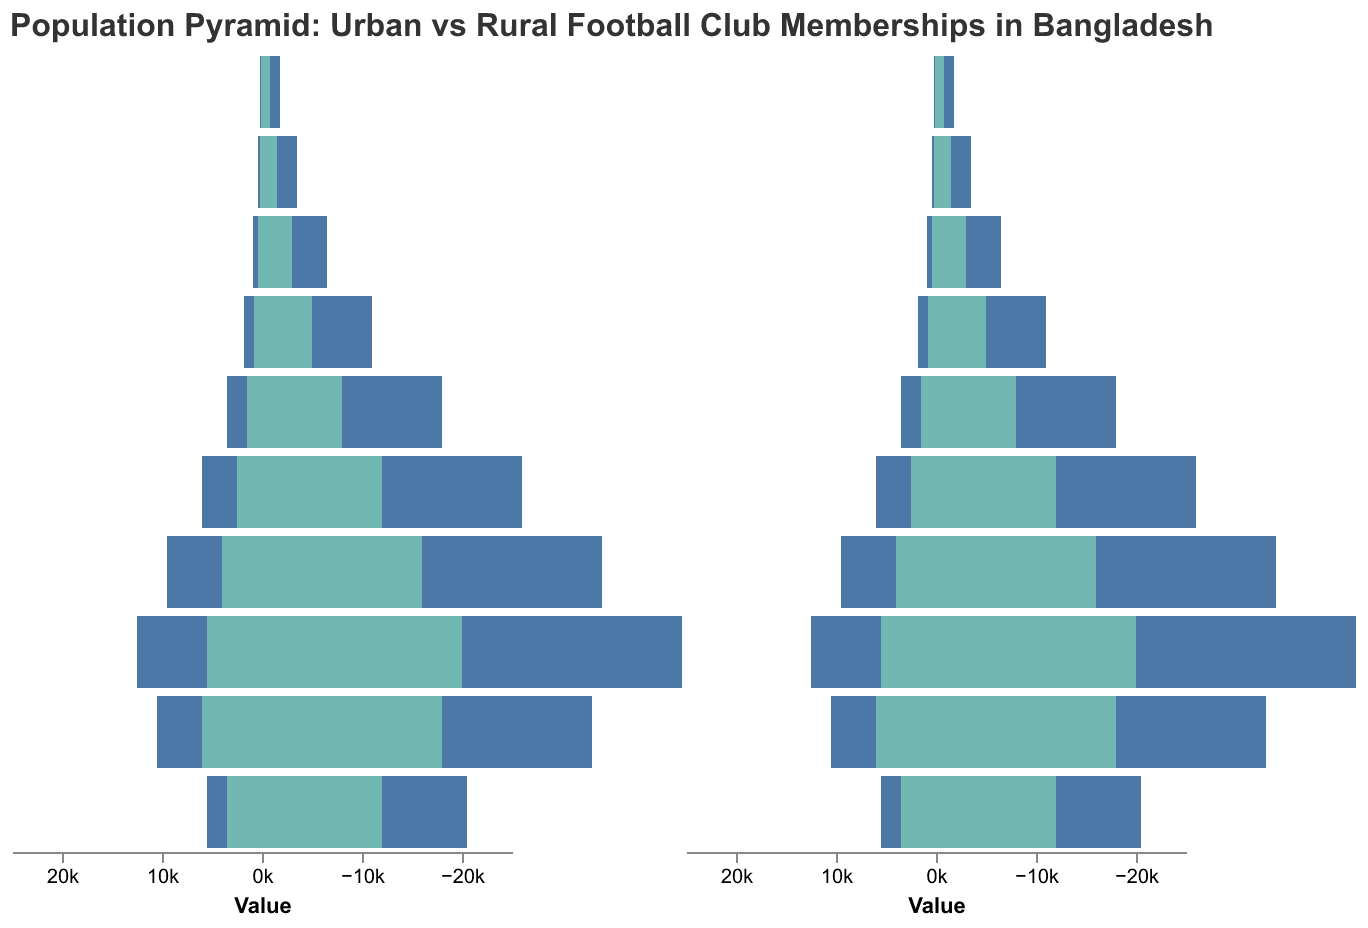How many age groups are shown in the football club membership population pyramid? Count the number of age groups listed on the y-axis.
Answer: 10 What is the title of the population pyramid? The title is typically at the top of the figure, summarizing its content.
Answer: Population Pyramid: Urban vs Rural Football Club Memberships in Bangladesh Which age group has the highest number of Urban Male football club members? Look for the widest bar for Urban Male (negative side) and identify the corresponding age group.
Answer: 20-24 How does the number of Rural Female football club members in the 20-24 age group compare to the Urban Female members in the same group? Compare the width of the bars for Rural Female and Urban Female within the 20-24 age group on the positive side of the pyramid.
Answer: Rural Female: 5500, Urban Female: 7000 What is the total number of Urban Female football club members across all age groups? Sum the values for Urban Female memberships across all listed age groups.
Answer: 23300 In the 40-44 age group, do Urban Males or Rural Males have a higher number of club members? Compare the absolute values of Urban Male and Rural Male in the 40-44 age group.
Answer: Urban Male Which age group has the smallest difference between the number of Rural Male and Rural Female football club members? Calculate the difference (absolute value) between Rural Male and Rural Female for each age group and identify the smallest one.
Answer: 50-54 What is the most common color used to represent Urban Female football club members? Identify the color associated with Urban Female in the legend.
Answer: Orange In the age group 10-14, how many more Rural Male football club members are there compared to Urban Male members? Subtract the number of Urban Male members from the number of Rural Male members in the 10-14 age group.
Answer: 3500 Which age group has the least number of Urban Female football club members? Identify the smallest bar for Urban Female and note the corresponding age group.
Answer: 55-59 